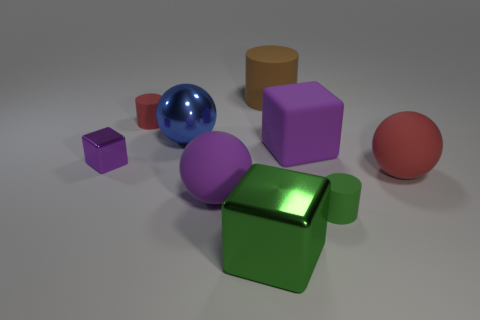Subtract all purple blocks. How many were subtracted if there are1purple blocks left? 1 Add 1 big rubber blocks. How many objects exist? 10 Subtract 0 purple cylinders. How many objects are left? 9 Subtract all cylinders. How many objects are left? 6 Subtract 3 spheres. How many spheres are left? 0 Subtract all purple cubes. Subtract all gray cylinders. How many cubes are left? 1 Subtract all yellow cubes. How many purple spheres are left? 1 Subtract all purple shiny objects. Subtract all large gray rubber cylinders. How many objects are left? 8 Add 2 big red rubber spheres. How many big red rubber spheres are left? 3 Add 4 red cylinders. How many red cylinders exist? 5 